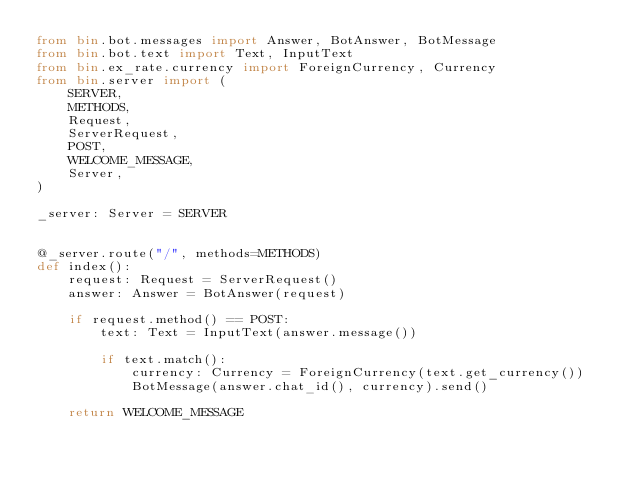Convert code to text. <code><loc_0><loc_0><loc_500><loc_500><_Python_>from bin.bot.messages import Answer, BotAnswer, BotMessage
from bin.bot.text import Text, InputText
from bin.ex_rate.currency import ForeignCurrency, Currency
from bin.server import (
    SERVER,
    METHODS,
    Request,
    ServerRequest,
    POST,
    WELCOME_MESSAGE,
    Server,
)

_server: Server = SERVER


@_server.route("/", methods=METHODS)
def index():
    request: Request = ServerRequest()
    answer: Answer = BotAnswer(request)

    if request.method() == POST:
        text: Text = InputText(answer.message())

        if text.match():
            currency: Currency = ForeignCurrency(text.get_currency())
            BotMessage(answer.chat_id(), currency).send()

    return WELCOME_MESSAGE
</code> 